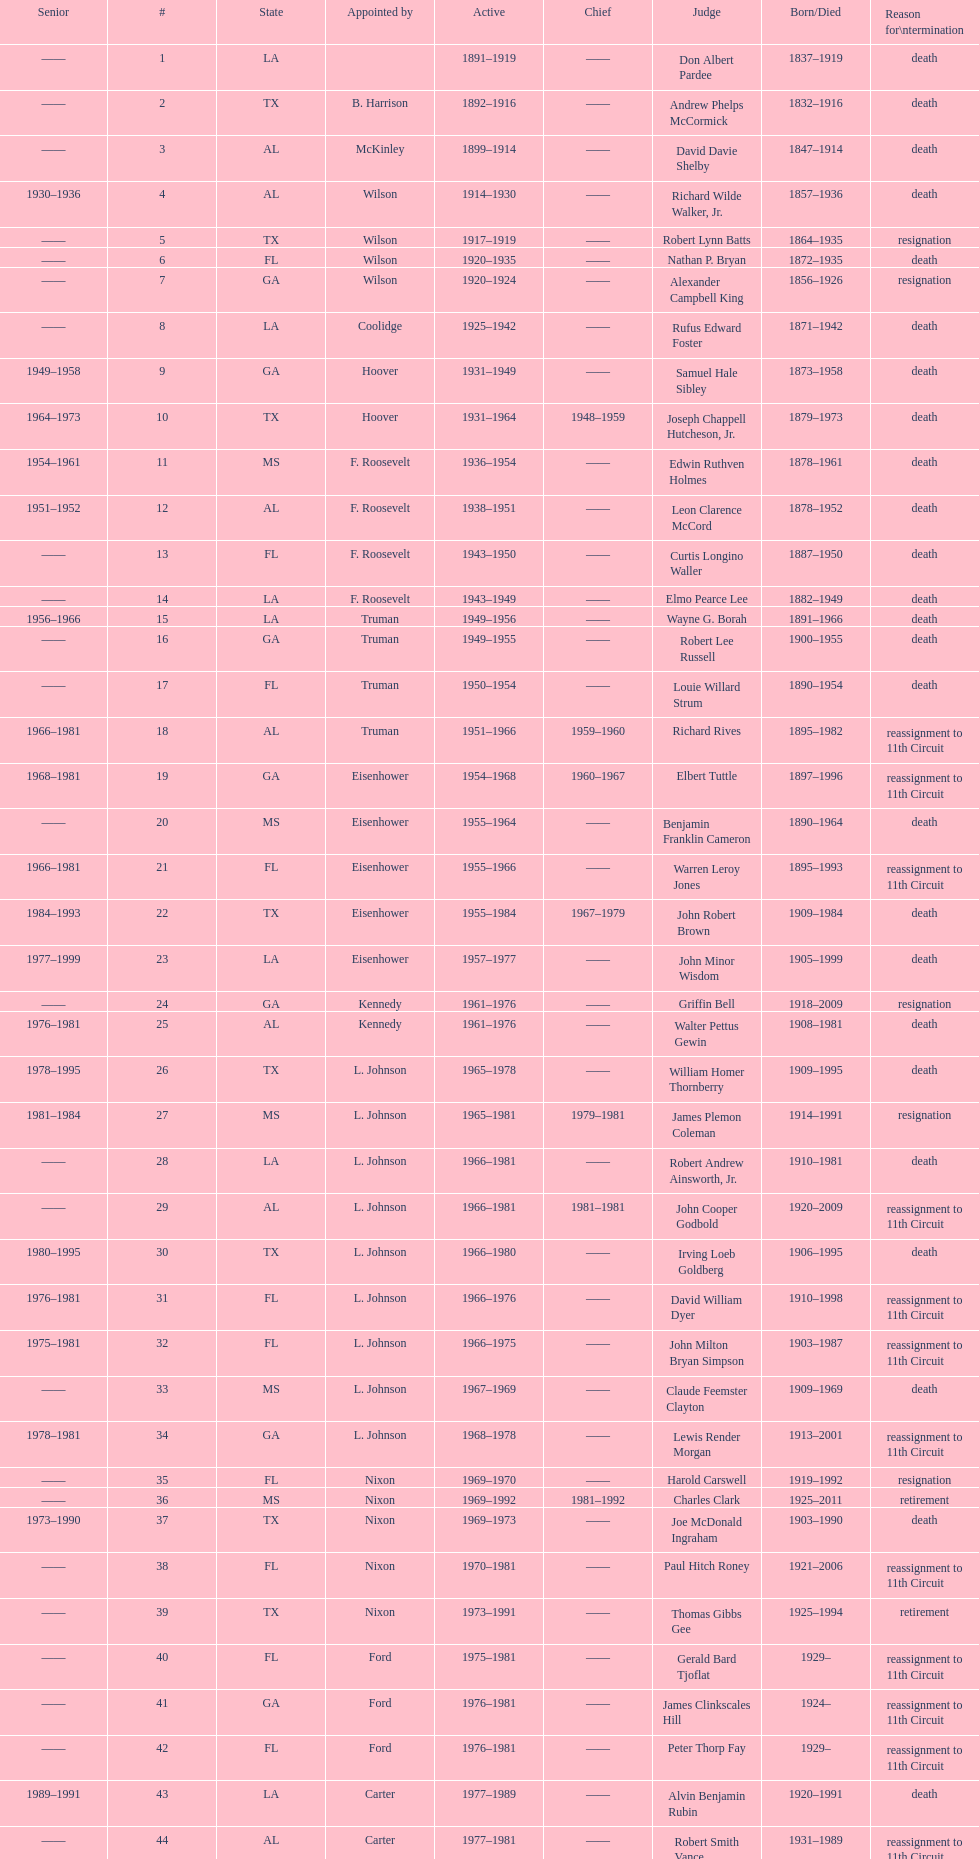Who was the next judge to resign after alexander campbell king? Griffin Bell. 